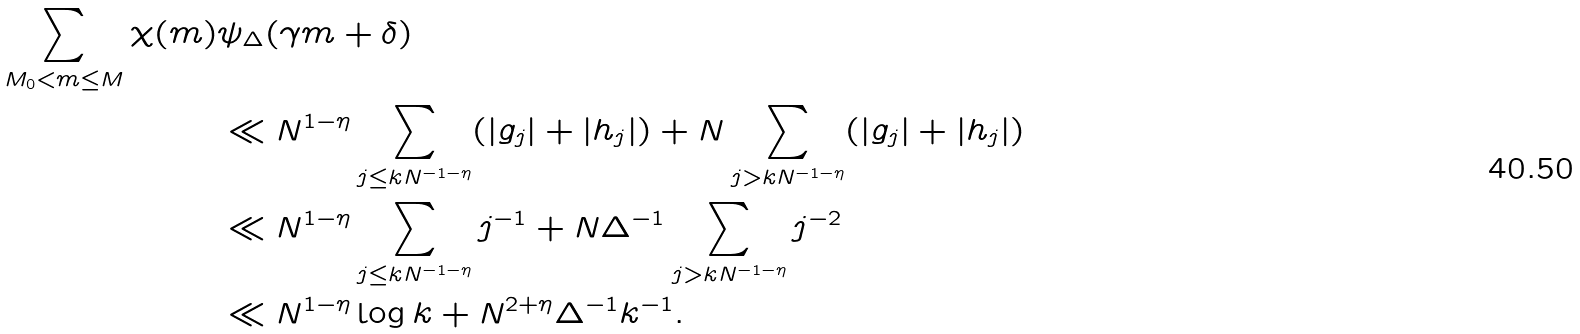<formula> <loc_0><loc_0><loc_500><loc_500>\sum _ { M _ { 0 } < m \leq M } \chi ( m ) & \psi _ { \Delta } ( \gamma m + \delta ) \\ & \ll N ^ { 1 - \eta } \sum _ { j \leq k N ^ { - 1 - \eta } } ( | g _ { j } | + | h _ { j } | ) + N \sum _ { j > k N ^ { - 1 - \eta } } ( | g _ { j } | + | h _ { j } | ) \\ & \ll N ^ { 1 - \eta } \sum _ { j \leq k N ^ { - 1 - \eta } } j ^ { - 1 } + N \Delta ^ { - 1 } \sum _ { j > k N ^ { - 1 - \eta } } j ^ { - 2 } \\ & \ll N ^ { 1 - \eta } \log k + N ^ { 2 + \eta } \Delta ^ { - 1 } k ^ { - 1 } .</formula> 